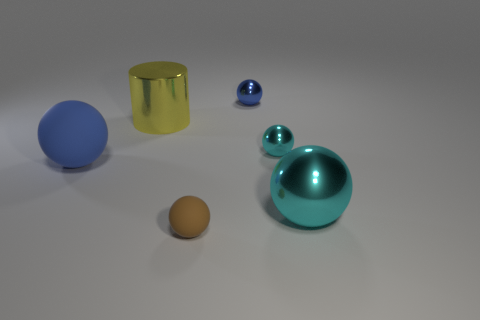Is there any other thing that is the same size as the yellow metallic object?
Provide a succinct answer. Yes. What number of metal things are right of the tiny matte object and on the left side of the tiny cyan object?
Keep it short and to the point. 1. There is a rubber object that is left of the cylinder; is its shape the same as the big cyan object?
Give a very brief answer. Yes. There is a cyan ball that is the same size as the brown rubber object; what is its material?
Make the answer very short. Metal. Are there the same number of big blue matte spheres right of the tiny blue shiny sphere and tiny balls that are left of the yellow cylinder?
Provide a short and direct response. Yes. What number of matte objects are on the right side of the big yellow metallic object left of the large sphere to the right of the tiny brown sphere?
Ensure brevity in your answer.  1. There is a shiny cylinder; is its color the same as the matte ball to the right of the yellow object?
Keep it short and to the point. No. There is a cylinder that is made of the same material as the tiny cyan object; what size is it?
Give a very brief answer. Large. Is the number of big blue things that are in front of the big cyan sphere greater than the number of large cylinders?
Your response must be concise. No. There is a tiny sphere behind the tiny shiny sphere in front of the big metal object behind the tiny cyan shiny thing; what is its material?
Make the answer very short. Metal. 